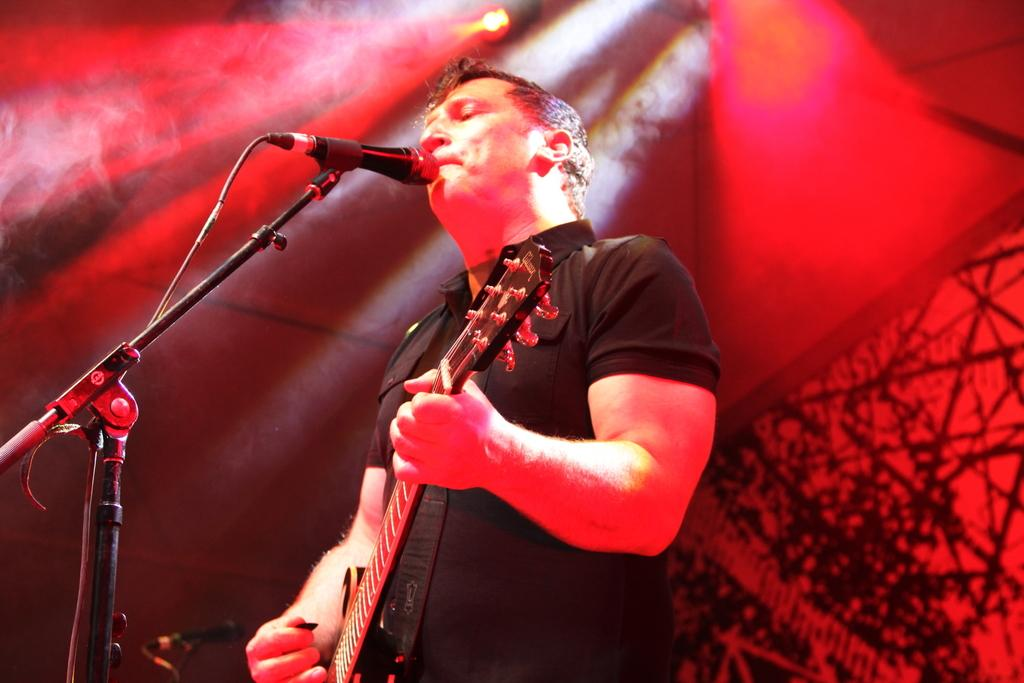What is the main subject of the image? There is a man standing in the center of the image. What is the man holding in his hand? The man is holding a guitar in his hand. What object is in front of the man? There is a microphone (mic) in front of the man. What can be seen in the background of the image? There is a wall and a light in the background of the image. What type of government is being discussed in the image? There is no discussion of government in the image; it features a man holding a guitar and standing near a microphone. How much does the fear weigh in the image? There is no fear present in the image, and therefore its weight cannot be determined. 